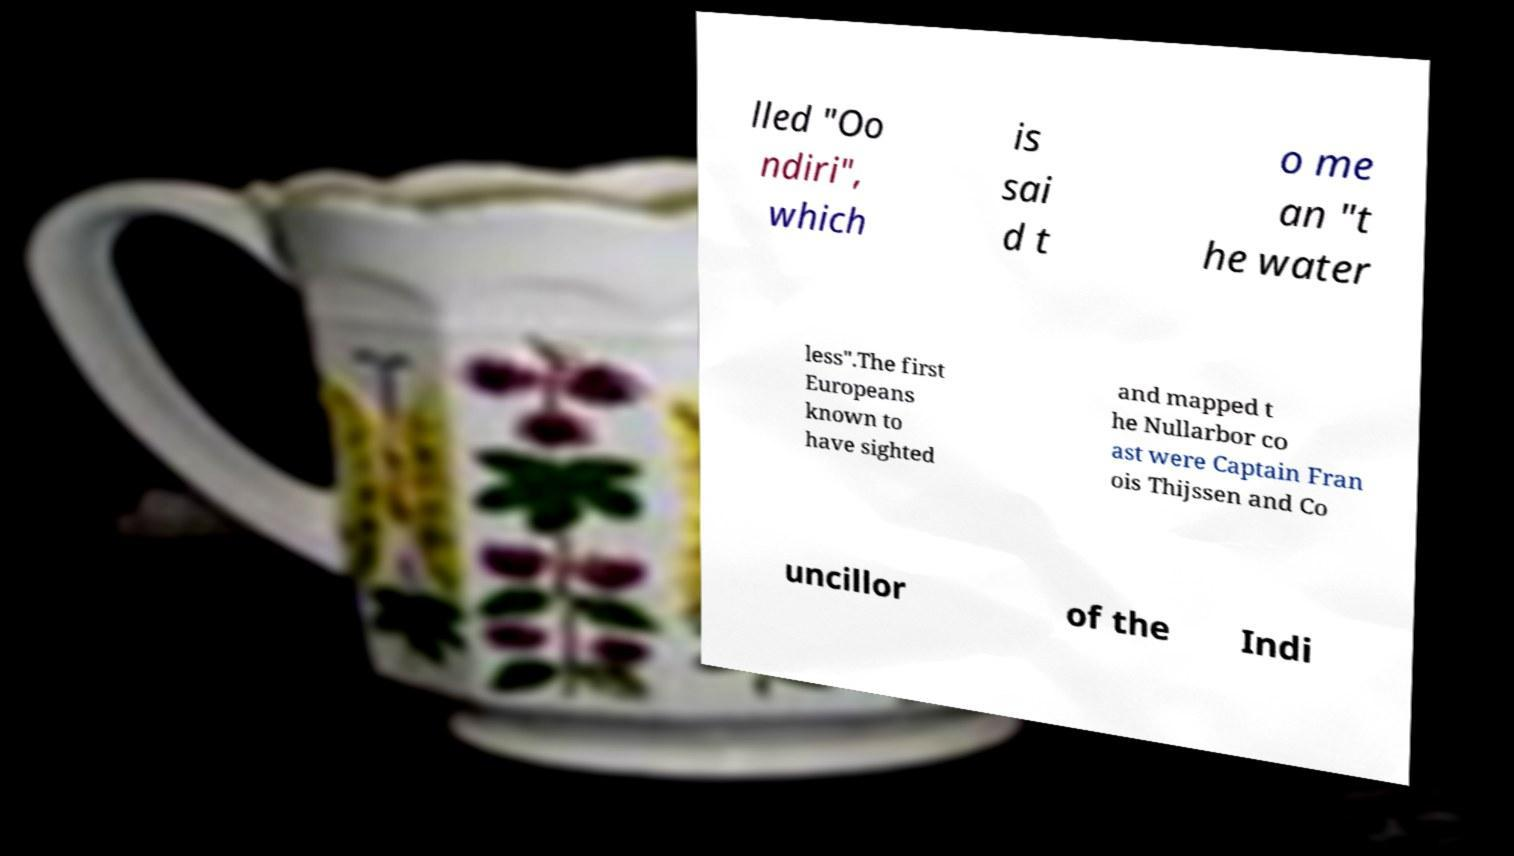Can you read and provide the text displayed in the image?This photo seems to have some interesting text. Can you extract and type it out for me? lled "Oo ndiri", which is sai d t o me an "t he water less".The first Europeans known to have sighted and mapped t he Nullarbor co ast were Captain Fran ois Thijssen and Co uncillor of the Indi 